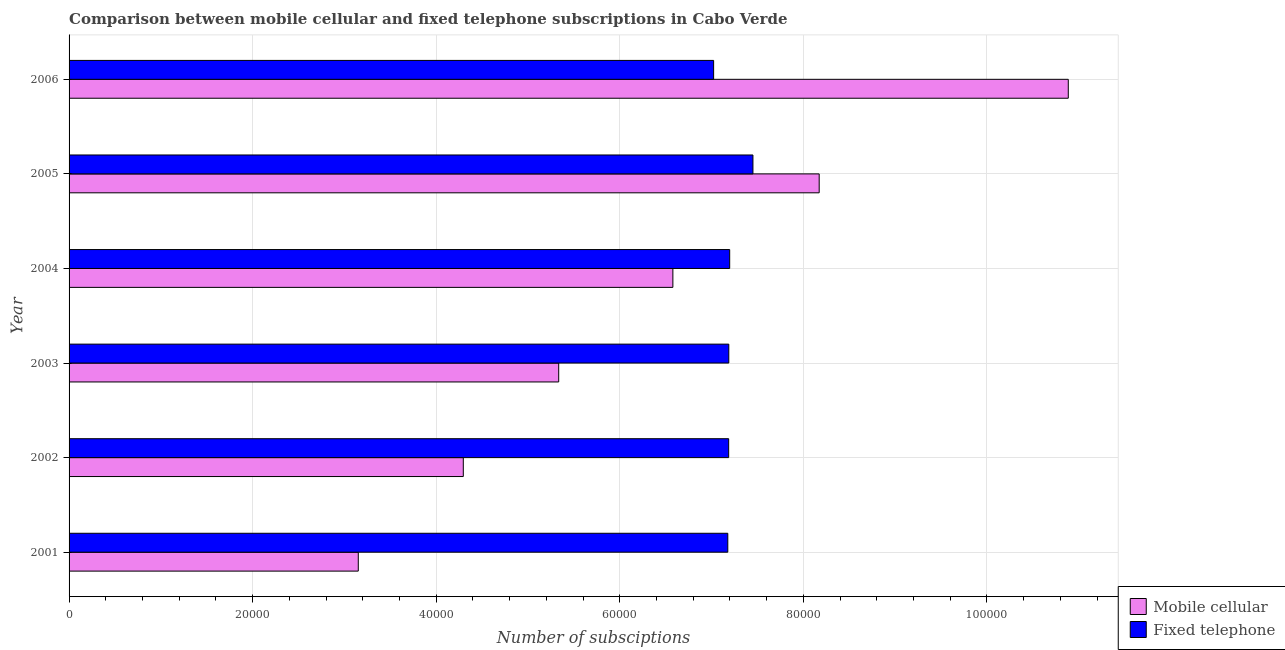How many different coloured bars are there?
Offer a very short reply. 2. Are the number of bars on each tick of the Y-axis equal?
Make the answer very short. Yes. How many bars are there on the 5th tick from the top?
Keep it short and to the point. 2. How many bars are there on the 2nd tick from the bottom?
Offer a very short reply. 2. In how many cases, is the number of bars for a given year not equal to the number of legend labels?
Make the answer very short. 0. What is the number of mobile cellular subscriptions in 2002?
Ensure brevity in your answer.  4.29e+04. Across all years, what is the maximum number of mobile cellular subscriptions?
Give a very brief answer. 1.09e+05. Across all years, what is the minimum number of mobile cellular subscriptions?
Your response must be concise. 3.15e+04. In which year was the number of fixed telephone subscriptions minimum?
Offer a terse response. 2006. What is the total number of mobile cellular subscriptions in the graph?
Provide a short and direct response. 3.84e+05. What is the difference between the number of mobile cellular subscriptions in 2005 and that in 2006?
Provide a short and direct response. -2.71e+04. What is the difference between the number of fixed telephone subscriptions in 2004 and the number of mobile cellular subscriptions in 2003?
Offer a very short reply. 1.86e+04. What is the average number of mobile cellular subscriptions per year?
Your answer should be compact. 6.40e+04. In the year 2002, what is the difference between the number of fixed telephone subscriptions and number of mobile cellular subscriptions?
Keep it short and to the point. 2.89e+04. What is the ratio of the number of mobile cellular subscriptions in 2003 to that in 2006?
Provide a short and direct response. 0.49. Is the number of fixed telephone subscriptions in 2001 less than that in 2005?
Offer a terse response. Yes. Is the difference between the number of mobile cellular subscriptions in 2004 and 2005 greater than the difference between the number of fixed telephone subscriptions in 2004 and 2005?
Your answer should be very brief. No. What is the difference between the highest and the second highest number of mobile cellular subscriptions?
Your answer should be compact. 2.71e+04. What is the difference between the highest and the lowest number of mobile cellular subscriptions?
Provide a short and direct response. 7.74e+04. Is the sum of the number of fixed telephone subscriptions in 2004 and 2006 greater than the maximum number of mobile cellular subscriptions across all years?
Your response must be concise. Yes. What does the 2nd bar from the top in 2006 represents?
Provide a short and direct response. Mobile cellular. What does the 1st bar from the bottom in 2001 represents?
Give a very brief answer. Mobile cellular. Are all the bars in the graph horizontal?
Ensure brevity in your answer.  Yes. Are the values on the major ticks of X-axis written in scientific E-notation?
Your response must be concise. No. Does the graph contain any zero values?
Your answer should be compact. No. Does the graph contain grids?
Your answer should be compact. Yes. Where does the legend appear in the graph?
Offer a very short reply. Bottom right. What is the title of the graph?
Provide a short and direct response. Comparison between mobile cellular and fixed telephone subscriptions in Cabo Verde. What is the label or title of the X-axis?
Your answer should be compact. Number of subsciptions. What is the label or title of the Y-axis?
Your answer should be very brief. Year. What is the Number of subsciptions of Mobile cellular in 2001?
Offer a terse response. 3.15e+04. What is the Number of subsciptions of Fixed telephone in 2001?
Provide a succinct answer. 7.18e+04. What is the Number of subsciptions of Mobile cellular in 2002?
Your response must be concise. 4.29e+04. What is the Number of subsciptions in Fixed telephone in 2002?
Your response must be concise. 7.19e+04. What is the Number of subsciptions in Mobile cellular in 2003?
Offer a terse response. 5.33e+04. What is the Number of subsciptions in Fixed telephone in 2003?
Make the answer very short. 7.19e+04. What is the Number of subsciptions of Mobile cellular in 2004?
Your answer should be compact. 6.58e+04. What is the Number of subsciptions of Fixed telephone in 2004?
Your answer should be very brief. 7.20e+04. What is the Number of subsciptions of Mobile cellular in 2005?
Provide a succinct answer. 8.17e+04. What is the Number of subsciptions in Fixed telephone in 2005?
Offer a very short reply. 7.45e+04. What is the Number of subsciptions of Mobile cellular in 2006?
Your answer should be very brief. 1.09e+05. What is the Number of subsciptions of Fixed telephone in 2006?
Your answer should be compact. 7.02e+04. Across all years, what is the maximum Number of subsciptions of Mobile cellular?
Your response must be concise. 1.09e+05. Across all years, what is the maximum Number of subsciptions of Fixed telephone?
Keep it short and to the point. 7.45e+04. Across all years, what is the minimum Number of subsciptions of Mobile cellular?
Ensure brevity in your answer.  3.15e+04. Across all years, what is the minimum Number of subsciptions in Fixed telephone?
Provide a short and direct response. 7.02e+04. What is the total Number of subsciptions of Mobile cellular in the graph?
Your answer should be very brief. 3.84e+05. What is the total Number of subsciptions in Fixed telephone in the graph?
Offer a terse response. 4.32e+05. What is the difference between the Number of subsciptions in Mobile cellular in 2001 and that in 2002?
Give a very brief answer. -1.14e+04. What is the difference between the Number of subsciptions of Fixed telephone in 2001 and that in 2002?
Keep it short and to the point. -96. What is the difference between the Number of subsciptions of Mobile cellular in 2001 and that in 2003?
Your answer should be very brief. -2.18e+04. What is the difference between the Number of subsciptions in Fixed telephone in 2001 and that in 2003?
Offer a terse response. -110. What is the difference between the Number of subsciptions of Mobile cellular in 2001 and that in 2004?
Offer a very short reply. -3.43e+04. What is the difference between the Number of subsciptions of Fixed telephone in 2001 and that in 2004?
Keep it short and to the point. -207. What is the difference between the Number of subsciptions of Mobile cellular in 2001 and that in 2005?
Ensure brevity in your answer.  -5.02e+04. What is the difference between the Number of subsciptions in Fixed telephone in 2001 and that in 2005?
Offer a very short reply. -2739. What is the difference between the Number of subsciptions of Mobile cellular in 2001 and that in 2006?
Make the answer very short. -7.74e+04. What is the difference between the Number of subsciptions of Fixed telephone in 2001 and that in 2006?
Offer a very short reply. 1544. What is the difference between the Number of subsciptions in Mobile cellular in 2002 and that in 2003?
Provide a succinct answer. -1.04e+04. What is the difference between the Number of subsciptions in Mobile cellular in 2002 and that in 2004?
Your answer should be compact. -2.28e+04. What is the difference between the Number of subsciptions in Fixed telephone in 2002 and that in 2004?
Your answer should be very brief. -111. What is the difference between the Number of subsciptions of Mobile cellular in 2002 and that in 2005?
Your answer should be very brief. -3.88e+04. What is the difference between the Number of subsciptions in Fixed telephone in 2002 and that in 2005?
Make the answer very short. -2643. What is the difference between the Number of subsciptions of Mobile cellular in 2002 and that in 2006?
Offer a terse response. -6.59e+04. What is the difference between the Number of subsciptions in Fixed telephone in 2002 and that in 2006?
Keep it short and to the point. 1640. What is the difference between the Number of subsciptions of Mobile cellular in 2003 and that in 2004?
Offer a very short reply. -1.24e+04. What is the difference between the Number of subsciptions in Fixed telephone in 2003 and that in 2004?
Provide a succinct answer. -97. What is the difference between the Number of subsciptions in Mobile cellular in 2003 and that in 2005?
Keep it short and to the point. -2.84e+04. What is the difference between the Number of subsciptions of Fixed telephone in 2003 and that in 2005?
Offer a terse response. -2629. What is the difference between the Number of subsciptions of Mobile cellular in 2003 and that in 2006?
Your answer should be compact. -5.55e+04. What is the difference between the Number of subsciptions of Fixed telephone in 2003 and that in 2006?
Provide a succinct answer. 1654. What is the difference between the Number of subsciptions of Mobile cellular in 2004 and that in 2005?
Offer a very short reply. -1.59e+04. What is the difference between the Number of subsciptions in Fixed telephone in 2004 and that in 2005?
Provide a short and direct response. -2532. What is the difference between the Number of subsciptions in Mobile cellular in 2004 and that in 2006?
Ensure brevity in your answer.  -4.31e+04. What is the difference between the Number of subsciptions of Fixed telephone in 2004 and that in 2006?
Your response must be concise. 1751. What is the difference between the Number of subsciptions in Mobile cellular in 2005 and that in 2006?
Offer a very short reply. -2.71e+04. What is the difference between the Number of subsciptions in Fixed telephone in 2005 and that in 2006?
Your answer should be very brief. 4283. What is the difference between the Number of subsciptions of Mobile cellular in 2001 and the Number of subsciptions of Fixed telephone in 2002?
Your response must be concise. -4.04e+04. What is the difference between the Number of subsciptions in Mobile cellular in 2001 and the Number of subsciptions in Fixed telephone in 2003?
Give a very brief answer. -4.04e+04. What is the difference between the Number of subsciptions of Mobile cellular in 2001 and the Number of subsciptions of Fixed telephone in 2004?
Keep it short and to the point. -4.05e+04. What is the difference between the Number of subsciptions in Mobile cellular in 2001 and the Number of subsciptions in Fixed telephone in 2005?
Give a very brief answer. -4.30e+04. What is the difference between the Number of subsciptions of Mobile cellular in 2001 and the Number of subsciptions of Fixed telephone in 2006?
Provide a short and direct response. -3.87e+04. What is the difference between the Number of subsciptions in Mobile cellular in 2002 and the Number of subsciptions in Fixed telephone in 2003?
Offer a terse response. -2.89e+04. What is the difference between the Number of subsciptions of Mobile cellular in 2002 and the Number of subsciptions of Fixed telephone in 2004?
Your answer should be compact. -2.90e+04. What is the difference between the Number of subsciptions in Mobile cellular in 2002 and the Number of subsciptions in Fixed telephone in 2005?
Provide a succinct answer. -3.16e+04. What is the difference between the Number of subsciptions in Mobile cellular in 2002 and the Number of subsciptions in Fixed telephone in 2006?
Offer a very short reply. -2.73e+04. What is the difference between the Number of subsciptions in Mobile cellular in 2003 and the Number of subsciptions in Fixed telephone in 2004?
Offer a very short reply. -1.86e+04. What is the difference between the Number of subsciptions in Mobile cellular in 2003 and the Number of subsciptions in Fixed telephone in 2005?
Your answer should be very brief. -2.12e+04. What is the difference between the Number of subsciptions in Mobile cellular in 2003 and the Number of subsciptions in Fixed telephone in 2006?
Keep it short and to the point. -1.69e+04. What is the difference between the Number of subsciptions in Mobile cellular in 2004 and the Number of subsciptions in Fixed telephone in 2005?
Make the answer very short. -8723. What is the difference between the Number of subsciptions of Mobile cellular in 2004 and the Number of subsciptions of Fixed telephone in 2006?
Offer a very short reply. -4440. What is the difference between the Number of subsciptions in Mobile cellular in 2005 and the Number of subsciptions in Fixed telephone in 2006?
Provide a short and direct response. 1.15e+04. What is the average Number of subsciptions in Mobile cellular per year?
Your answer should be very brief. 6.40e+04. What is the average Number of subsciptions of Fixed telephone per year?
Keep it short and to the point. 7.20e+04. In the year 2001, what is the difference between the Number of subsciptions in Mobile cellular and Number of subsciptions in Fixed telephone?
Offer a terse response. -4.03e+04. In the year 2002, what is the difference between the Number of subsciptions of Mobile cellular and Number of subsciptions of Fixed telephone?
Offer a terse response. -2.89e+04. In the year 2003, what is the difference between the Number of subsciptions of Mobile cellular and Number of subsciptions of Fixed telephone?
Provide a short and direct response. -1.85e+04. In the year 2004, what is the difference between the Number of subsciptions of Mobile cellular and Number of subsciptions of Fixed telephone?
Ensure brevity in your answer.  -6191. In the year 2005, what is the difference between the Number of subsciptions of Mobile cellular and Number of subsciptions of Fixed telephone?
Make the answer very short. 7218. In the year 2006, what is the difference between the Number of subsciptions of Mobile cellular and Number of subsciptions of Fixed telephone?
Keep it short and to the point. 3.86e+04. What is the ratio of the Number of subsciptions in Mobile cellular in 2001 to that in 2002?
Your answer should be compact. 0.73. What is the ratio of the Number of subsciptions in Mobile cellular in 2001 to that in 2003?
Your answer should be compact. 0.59. What is the ratio of the Number of subsciptions in Fixed telephone in 2001 to that in 2003?
Keep it short and to the point. 1. What is the ratio of the Number of subsciptions of Mobile cellular in 2001 to that in 2004?
Provide a succinct answer. 0.48. What is the ratio of the Number of subsciptions of Fixed telephone in 2001 to that in 2004?
Your answer should be compact. 1. What is the ratio of the Number of subsciptions in Mobile cellular in 2001 to that in 2005?
Give a very brief answer. 0.39. What is the ratio of the Number of subsciptions in Fixed telephone in 2001 to that in 2005?
Offer a terse response. 0.96. What is the ratio of the Number of subsciptions in Mobile cellular in 2001 to that in 2006?
Make the answer very short. 0.29. What is the ratio of the Number of subsciptions of Fixed telephone in 2001 to that in 2006?
Make the answer very short. 1.02. What is the ratio of the Number of subsciptions of Mobile cellular in 2002 to that in 2003?
Your response must be concise. 0.81. What is the ratio of the Number of subsciptions of Fixed telephone in 2002 to that in 2003?
Offer a terse response. 1. What is the ratio of the Number of subsciptions of Mobile cellular in 2002 to that in 2004?
Your response must be concise. 0.65. What is the ratio of the Number of subsciptions in Mobile cellular in 2002 to that in 2005?
Give a very brief answer. 0.53. What is the ratio of the Number of subsciptions of Fixed telephone in 2002 to that in 2005?
Ensure brevity in your answer.  0.96. What is the ratio of the Number of subsciptions of Mobile cellular in 2002 to that in 2006?
Your response must be concise. 0.39. What is the ratio of the Number of subsciptions of Fixed telephone in 2002 to that in 2006?
Make the answer very short. 1.02. What is the ratio of the Number of subsciptions of Mobile cellular in 2003 to that in 2004?
Provide a succinct answer. 0.81. What is the ratio of the Number of subsciptions in Mobile cellular in 2003 to that in 2005?
Provide a short and direct response. 0.65. What is the ratio of the Number of subsciptions in Fixed telephone in 2003 to that in 2005?
Make the answer very short. 0.96. What is the ratio of the Number of subsciptions in Mobile cellular in 2003 to that in 2006?
Provide a succinct answer. 0.49. What is the ratio of the Number of subsciptions of Fixed telephone in 2003 to that in 2006?
Keep it short and to the point. 1.02. What is the ratio of the Number of subsciptions of Mobile cellular in 2004 to that in 2005?
Offer a very short reply. 0.8. What is the ratio of the Number of subsciptions in Fixed telephone in 2004 to that in 2005?
Ensure brevity in your answer.  0.97. What is the ratio of the Number of subsciptions of Mobile cellular in 2004 to that in 2006?
Provide a short and direct response. 0.6. What is the ratio of the Number of subsciptions of Fixed telephone in 2004 to that in 2006?
Provide a succinct answer. 1.02. What is the ratio of the Number of subsciptions in Mobile cellular in 2005 to that in 2006?
Your answer should be very brief. 0.75. What is the ratio of the Number of subsciptions in Fixed telephone in 2005 to that in 2006?
Provide a succinct answer. 1.06. What is the difference between the highest and the second highest Number of subsciptions in Mobile cellular?
Provide a succinct answer. 2.71e+04. What is the difference between the highest and the second highest Number of subsciptions of Fixed telephone?
Ensure brevity in your answer.  2532. What is the difference between the highest and the lowest Number of subsciptions in Mobile cellular?
Ensure brevity in your answer.  7.74e+04. What is the difference between the highest and the lowest Number of subsciptions in Fixed telephone?
Your response must be concise. 4283. 